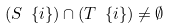<formula> <loc_0><loc_0><loc_500><loc_500>( S \ \{ i \} ) \cap ( T \ \{ i \} ) \ne \emptyset</formula> 